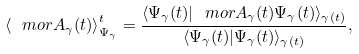<formula> <loc_0><loc_0><loc_500><loc_500>\left \langle \ m o r { A } _ { \gamma } ( t ) \right \rangle _ { \Psi _ { \gamma } } ^ { t } = \frac { \langle \Psi _ { \gamma } ( t ) | \ m o r { A } _ { \gamma } ( t ) \Psi _ { \gamma } ( t ) \rangle _ { \gamma ( t ) } } { \langle \Psi _ { \gamma } ( t ) | \Psi _ { \gamma } ( t ) \rangle _ { \gamma ( t ) } } ,</formula> 